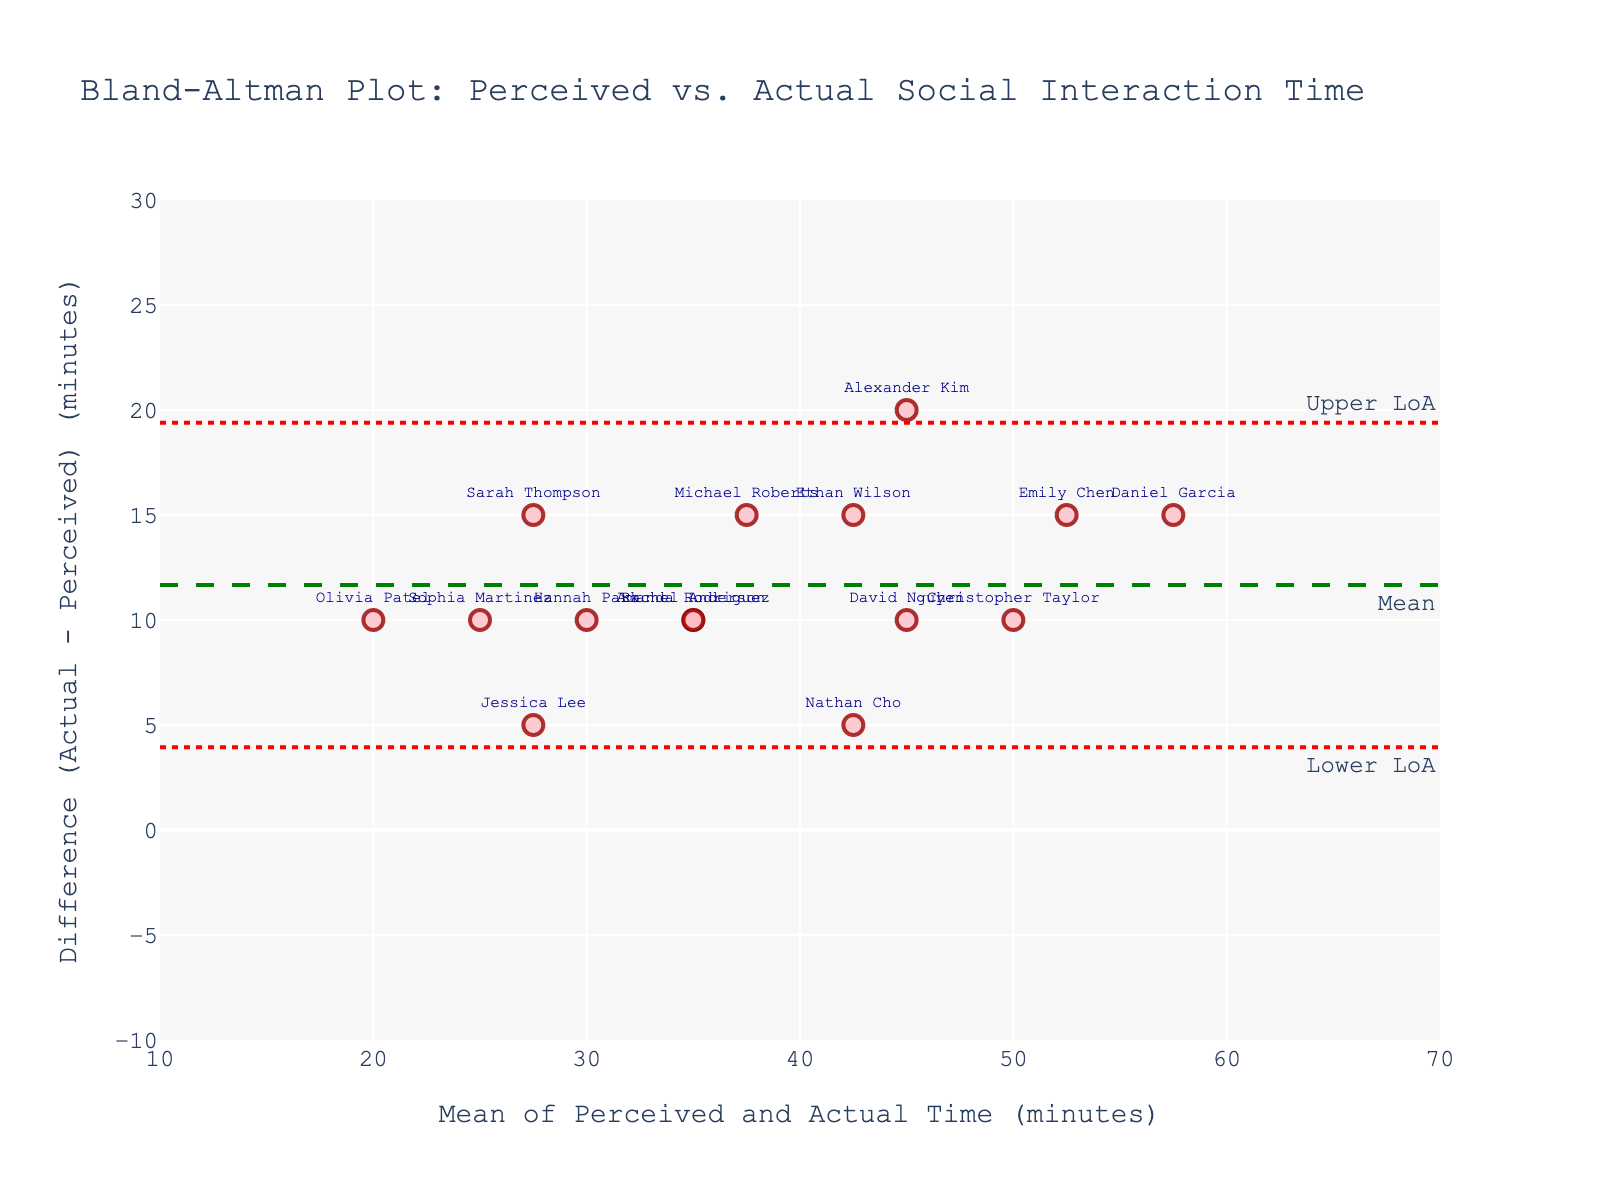What is the title of the plot? The title can be found at the top center of the plot. By looking at the given data, the title is "Bland-Altman Plot: Perceived vs. Actual Social Interaction Time".
Answer: Bland-Altman Plot: Perceived vs. Actual Social Interaction Time What do the x-axis and y-axis represent? The labels for the axes are indicated on the plot. The x-axis represents the "Mean of Perceived and Actual Time (minutes)" and the y-axis represents the "Difference (Actual - Perceived) (minutes)".
Answer: Mean of Perceived and Actual Time (minutes) and Difference (Actual - Perceived) (minutes) How many data points are shown on the plot? Each marker on the plot represents a data point. By counting the markers, we find there are 15 data points.
Answer: 15 What is the mean difference of the actual and perceived times? The mean difference is shown by the green dashed line labeled "Mean" on the plot.
Answer: Mean Are there any students whose perceived and actual times are equal? If the actual and perceived times are equal, the difference will be zero. Checking the y-axis, none of the data points lie exactly on the y=0 line.
Answer: No What's the range of the differences between actual and perceived times? The y-axis range is given from -10 to 30. The data points range from 5 to 25 minutes, so the difference ranges from 5 to 25 minutes.
Answer: 5 to 25 Who has the maximum positive difference between actual and perceived times? The student with the maximum positive difference can be identified by the highest data point on the y-axis, annotated with "Daniel Garcia" at the position (57.5, 15).
Answer: Daniel Garcia What are the upper and lower limits of agreement? The upper and lower limits of agreement are shown by the red dotted lines, labeled "Upper LoA" and "Lower LoA".
Answer: Upper LoA and Lower LoA Which students have a greater perceived time than actual time? For students with greater perceived times than actual times, the data points would be below the zero line on the y-axis. However, there are no such points in this dataset.
Answer: None 